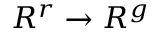<formula> <loc_0><loc_0><loc_500><loc_500>R ^ { r } \to R ^ { g }</formula> 